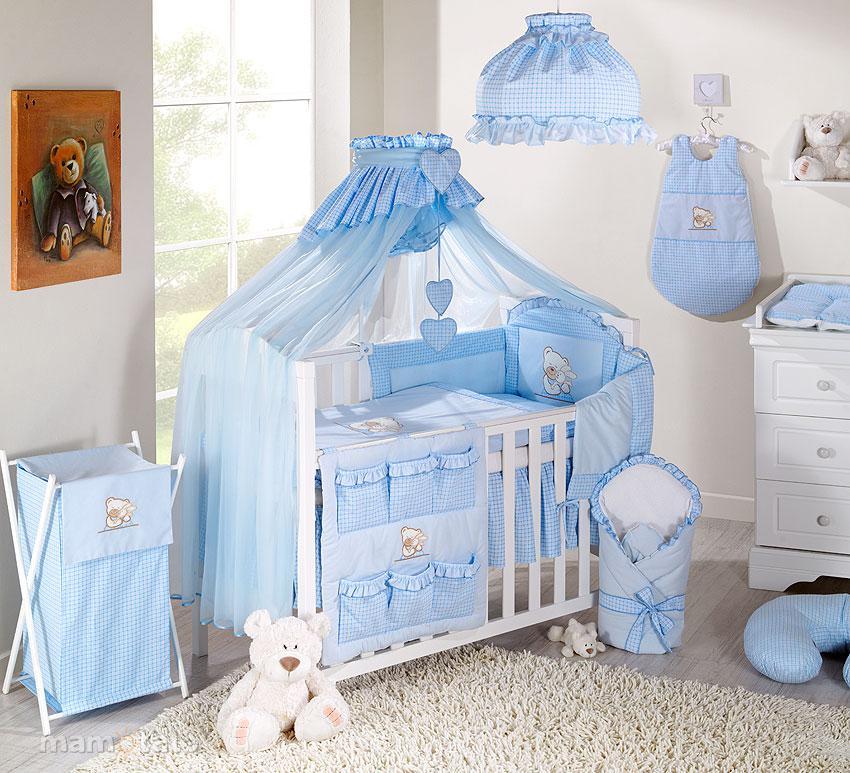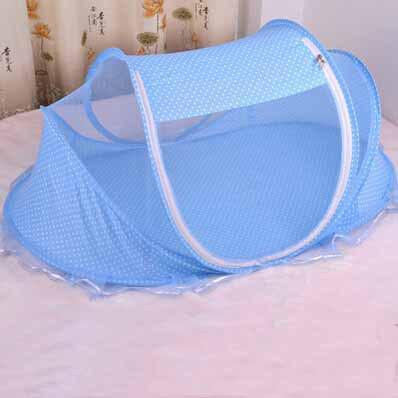The first image is the image on the left, the second image is the image on the right. For the images displayed, is the sentence "There are two blue canopies with at least one zip tent." factually correct? Answer yes or no. Yes. The first image is the image on the left, the second image is the image on the right. Analyze the images presented: Is the assertion "There is a stuffed animal in the left image." valid? Answer yes or no. Yes. 